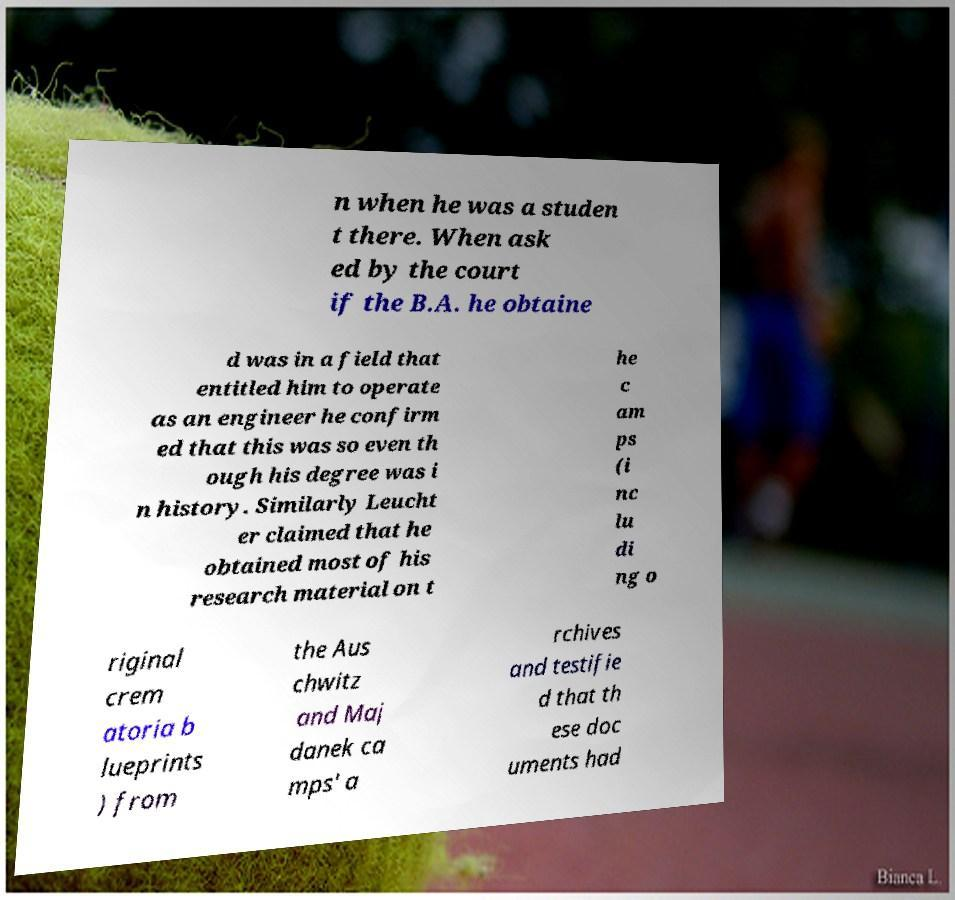Could you assist in decoding the text presented in this image and type it out clearly? n when he was a studen t there. When ask ed by the court if the B.A. he obtaine d was in a field that entitled him to operate as an engineer he confirm ed that this was so even th ough his degree was i n history. Similarly Leucht er claimed that he obtained most of his research material on t he c am ps (i nc lu di ng o riginal crem atoria b lueprints ) from the Aus chwitz and Maj danek ca mps' a rchives and testifie d that th ese doc uments had 